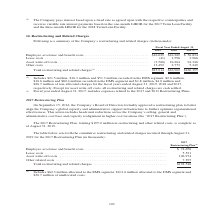According to Jabil Circuit's financial document, What did the amounts in fiscal year ended August 31, 2017 include? expenses related to the 2017 and 2013 Restructuring Plans.. The document states: "d. (2) Fiscal year ended August 31, 2017, includes expenses related to the 2017 and 2013 Restructuring Plans...." Also, Which years does the table provide information for the Company’s restructuring and related charges? The document contains multiple relevant values: 2019, 2018, 2017. From the document: "est payments based on the one-month LIBOR for the 2017 Term Loan Facility and the three-month LIBOR for the 2018 Term Loan Facility. 2019 2018 2017 (2..." Also, What were the lease costs in 2019? According to the financial document, (41) (in thousands). The relevant text states: "fit costs . $16,029 $16,269 $ 56,834 Lease costs . (41) 1,596 3,966 Asset write-off costs . (3,566) 16,264 94,346 Other costs . 13,492 2,773 5,249..." Also, can you calculate: What was the change in Employee severance and benefit costs between 2017 and 2018? Based on the calculation: 16,269-56,834, the result is -40565 (in thousands). This is based on the information: "Employee severance and benefit costs . $16,029 $16,269 $ 56,834 Lease costs . (41) 1,596 3,966 Asset write-off costs . (3,566) 16,264 94,346 Other costs . e severance and benefit costs . $16,029 $16,2..." The key data points involved are: 16,269, 56,834. Also, can you calculate: What was the change in Other costs between 2018 and 2019? Based on the calculation: 13,492-2,773, the result is 10719 (in thousands). This is based on the information: "osts . (3,566) 16,264 94,346 Other costs . 13,492 2,773 5,249 e-off costs . (3,566) 16,264 94,346 Other costs . 13,492 2,773 5,249..." The key data points involved are: 13,492, 2,773. Also, can you calculate: What was the percentage change in the Total restructuring and related charges between 2018 and 2019? To answer this question, I need to perform calculations using the financial data. The calculation is: (25,914-36,902)/36,902, which equals -29.78 (percentage). This is based on the information: "restructuring and related charges (1) . $25,914 $36,902 $160,395 Total restructuring and related charges (1) . $25,914 $36,902 $160,395..." The key data points involved are: 25,914, 36,902. 